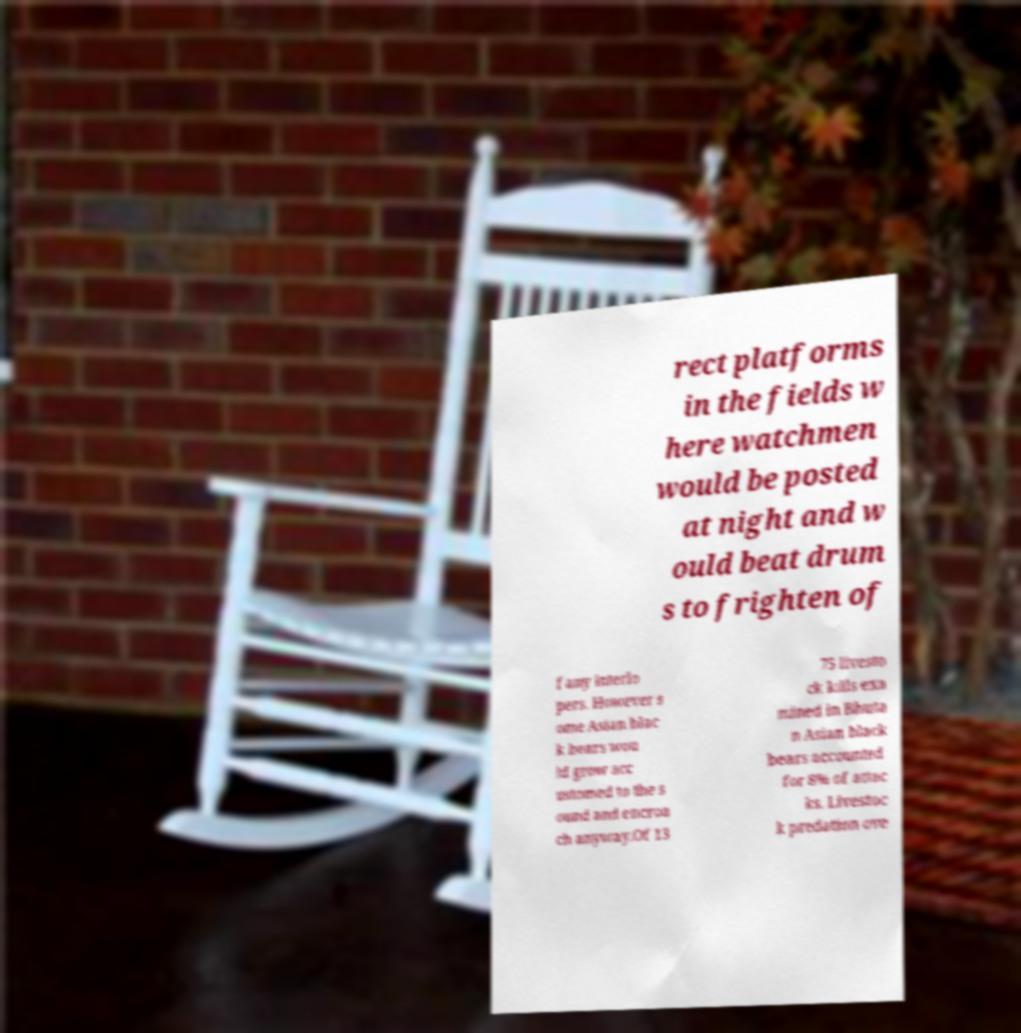Can you accurately transcribe the text from the provided image for me? rect platforms in the fields w here watchmen would be posted at night and w ould beat drum s to frighten of f any interlo pers. However s ome Asian blac k bears wou ld grow acc ustomed to the s ound and encroa ch anyway.Of 13 75 livesto ck kills exa mined in Bhuta n Asian black bears accounted for 8% of attac ks. Livestoc k predation ove 